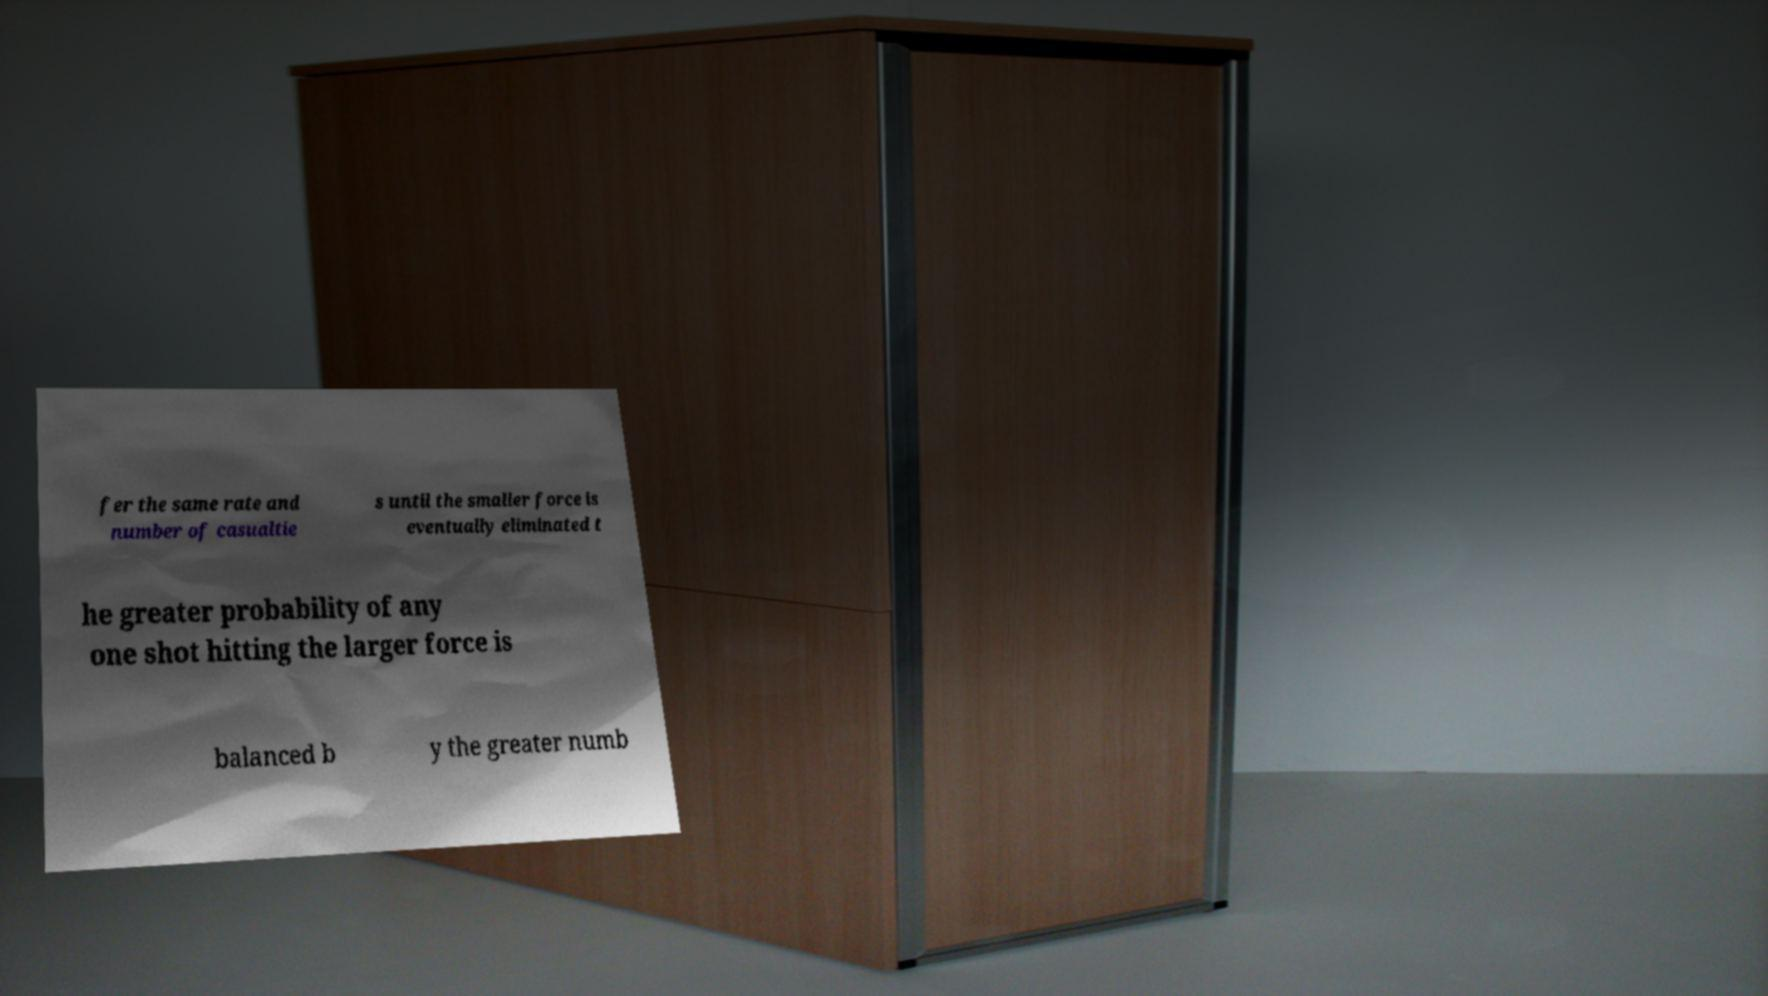What messages or text are displayed in this image? I need them in a readable, typed format. fer the same rate and number of casualtie s until the smaller force is eventually eliminated t he greater probability of any one shot hitting the larger force is balanced b y the greater numb 